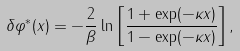Convert formula to latex. <formula><loc_0><loc_0><loc_500><loc_500>\delta \varphi ^ { * } ( x ) = - \frac { 2 } { \beta } \ln \left [ \frac { 1 + \exp ( - \kappa x ) } { 1 - \exp ( - \kappa x ) } \right ] ,</formula> 